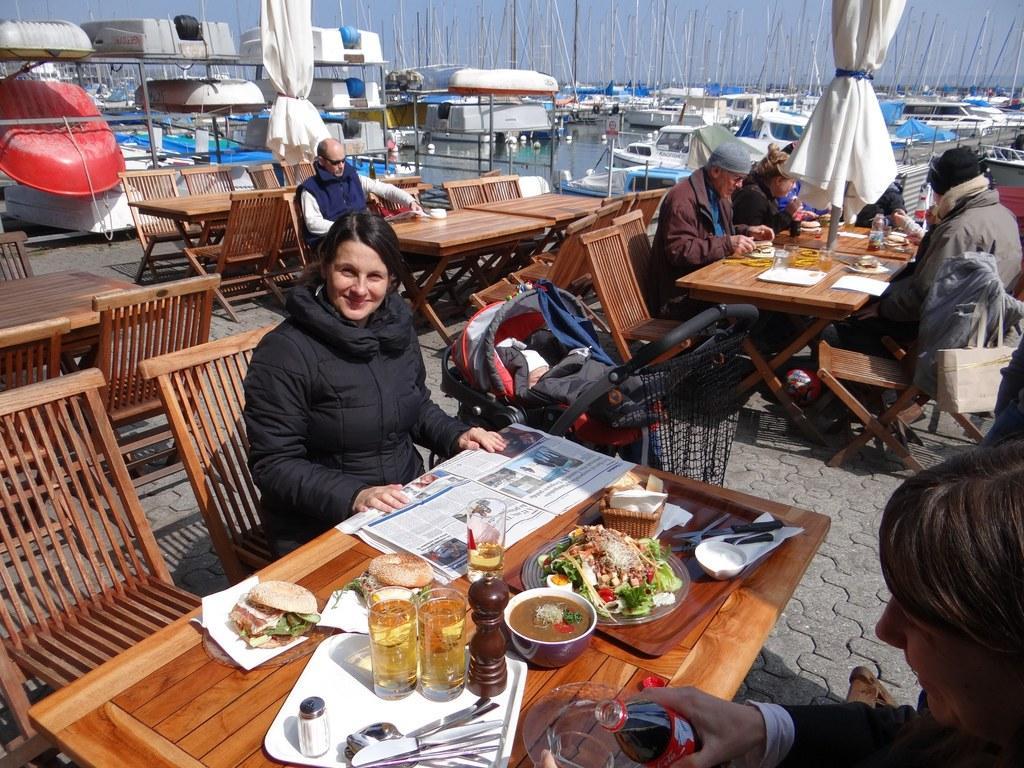In one or two sentences, can you explain what this image depicts? There is a group of a people. They are sitting on a chair. There is a table. There is a bottle,bowl,fork,knife,pizza,food item on a table. We can see the background there is a boat,curtain,sea. 